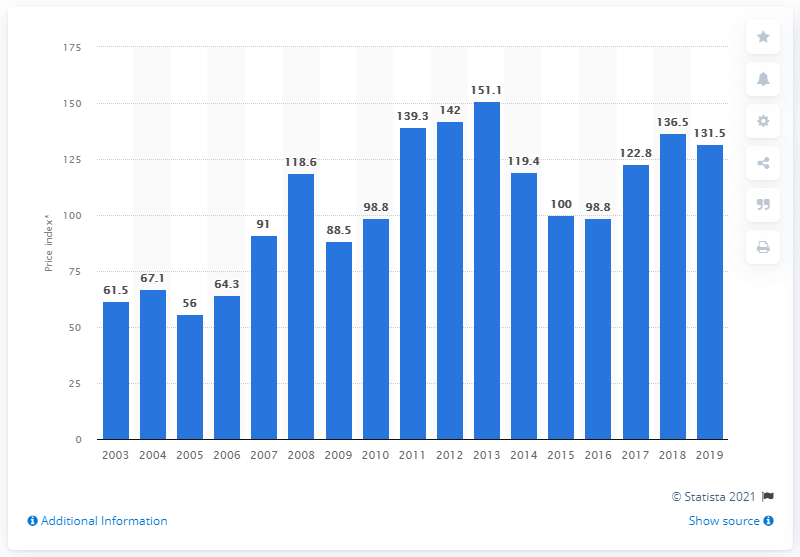Mention a couple of crucial points in this snapshot. In 2011, the price index of wheat was 139.3. 